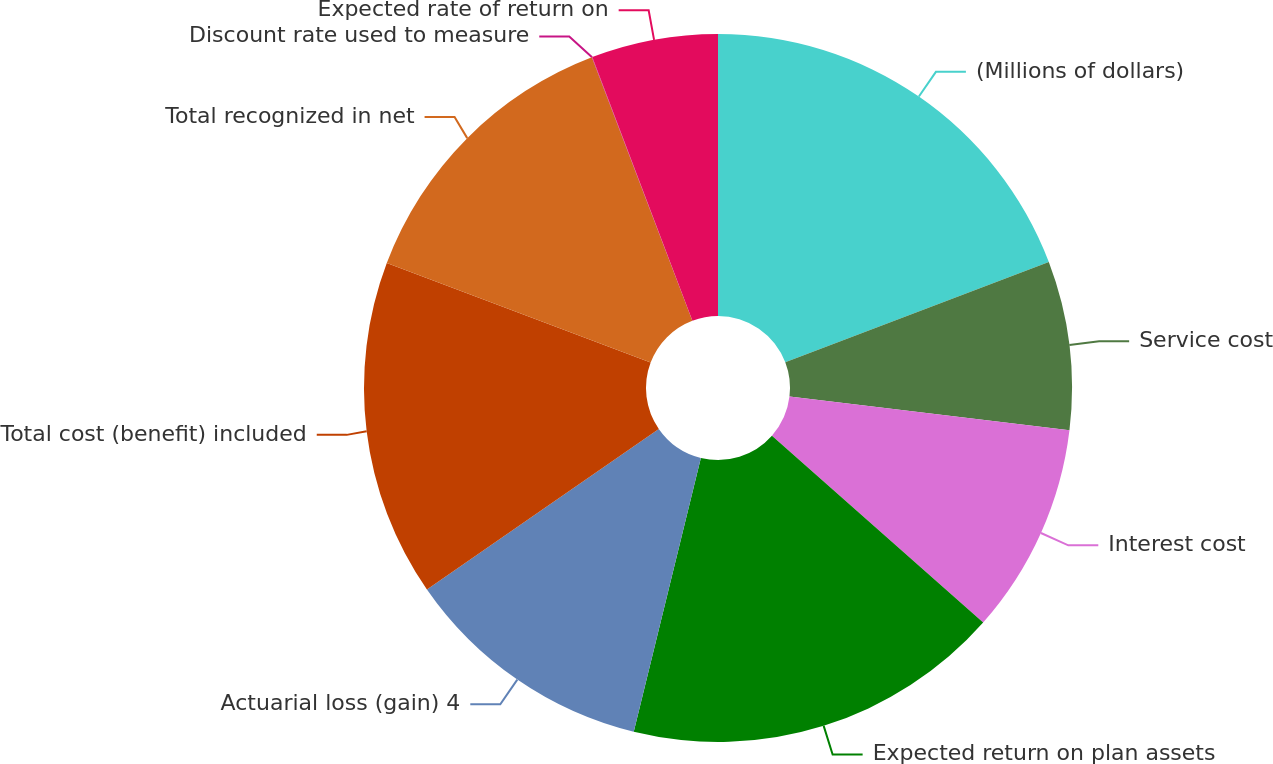<chart> <loc_0><loc_0><loc_500><loc_500><pie_chart><fcel>(Millions of dollars)<fcel>Service cost<fcel>Interest cost<fcel>Expected return on plan assets<fcel>Actuarial loss (gain) 4<fcel>Total cost (benefit) included<fcel>Total recognized in net<fcel>Discount rate used to measure<fcel>Expected rate of return on<nl><fcel>19.21%<fcel>7.7%<fcel>9.62%<fcel>17.3%<fcel>11.54%<fcel>15.38%<fcel>13.46%<fcel>0.02%<fcel>5.78%<nl></chart> 